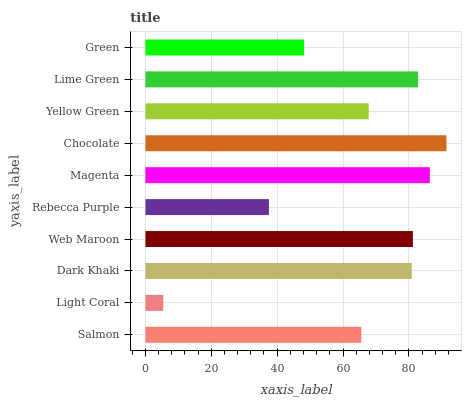Is Light Coral the minimum?
Answer yes or no. Yes. Is Chocolate the maximum?
Answer yes or no. Yes. Is Dark Khaki the minimum?
Answer yes or no. No. Is Dark Khaki the maximum?
Answer yes or no. No. Is Dark Khaki greater than Light Coral?
Answer yes or no. Yes. Is Light Coral less than Dark Khaki?
Answer yes or no. Yes. Is Light Coral greater than Dark Khaki?
Answer yes or no. No. Is Dark Khaki less than Light Coral?
Answer yes or no. No. Is Dark Khaki the high median?
Answer yes or no. Yes. Is Yellow Green the low median?
Answer yes or no. Yes. Is Lime Green the high median?
Answer yes or no. No. Is Magenta the low median?
Answer yes or no. No. 